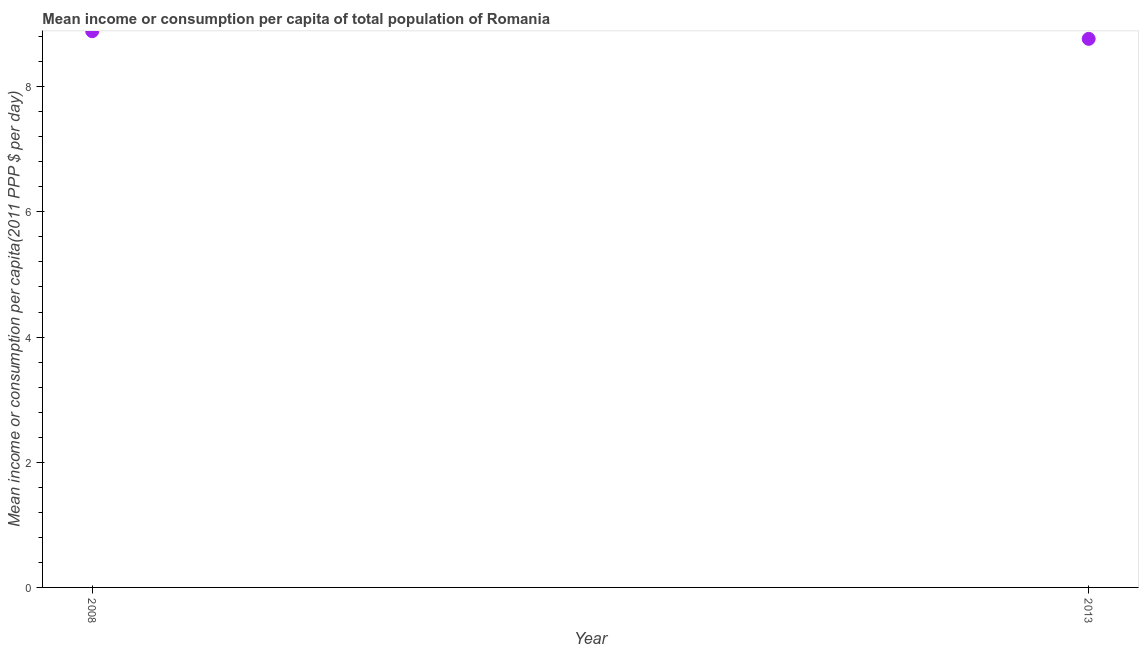What is the mean income or consumption in 2013?
Ensure brevity in your answer.  8.76. Across all years, what is the maximum mean income or consumption?
Give a very brief answer. 8.89. Across all years, what is the minimum mean income or consumption?
Make the answer very short. 8.76. What is the sum of the mean income or consumption?
Make the answer very short. 17.65. What is the difference between the mean income or consumption in 2008 and 2013?
Your answer should be compact. 0.12. What is the average mean income or consumption per year?
Offer a terse response. 8.83. What is the median mean income or consumption?
Provide a short and direct response. 8.83. In how many years, is the mean income or consumption greater than 4.8 $?
Offer a terse response. 2. What is the ratio of the mean income or consumption in 2008 to that in 2013?
Ensure brevity in your answer.  1.01. How many dotlines are there?
Offer a terse response. 1. How many years are there in the graph?
Keep it short and to the point. 2. What is the title of the graph?
Offer a terse response. Mean income or consumption per capita of total population of Romania. What is the label or title of the X-axis?
Give a very brief answer. Year. What is the label or title of the Y-axis?
Offer a very short reply. Mean income or consumption per capita(2011 PPP $ per day). What is the Mean income or consumption per capita(2011 PPP $ per day) in 2008?
Keep it short and to the point. 8.89. What is the Mean income or consumption per capita(2011 PPP $ per day) in 2013?
Ensure brevity in your answer.  8.76. What is the difference between the Mean income or consumption per capita(2011 PPP $ per day) in 2008 and 2013?
Your answer should be very brief. 0.12. What is the ratio of the Mean income or consumption per capita(2011 PPP $ per day) in 2008 to that in 2013?
Ensure brevity in your answer.  1.01. 